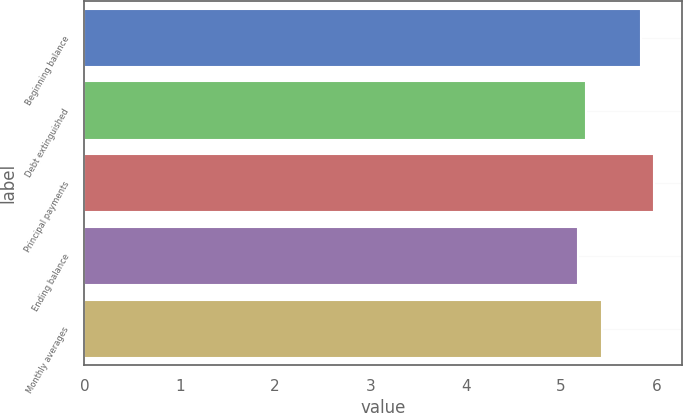<chart> <loc_0><loc_0><loc_500><loc_500><bar_chart><fcel>Beginning balance<fcel>Debt extinguished<fcel>Principal payments<fcel>Ending balance<fcel>Monthly averages<nl><fcel>5.84<fcel>5.26<fcel>5.97<fcel>5.18<fcel>5.43<nl></chart> 